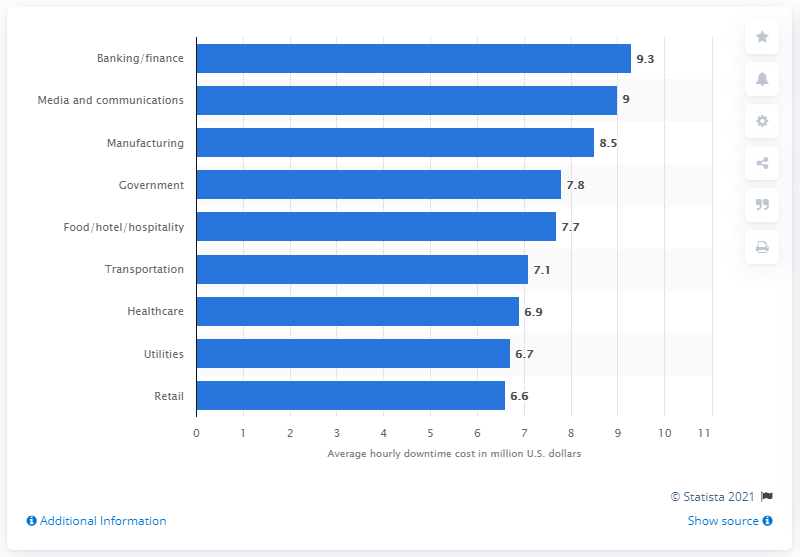Outline some significant characteristics in this image. As of May 2017, the banking/finance industry is estimated to lose approximately $9.3 dollars per hour of server downtime. 